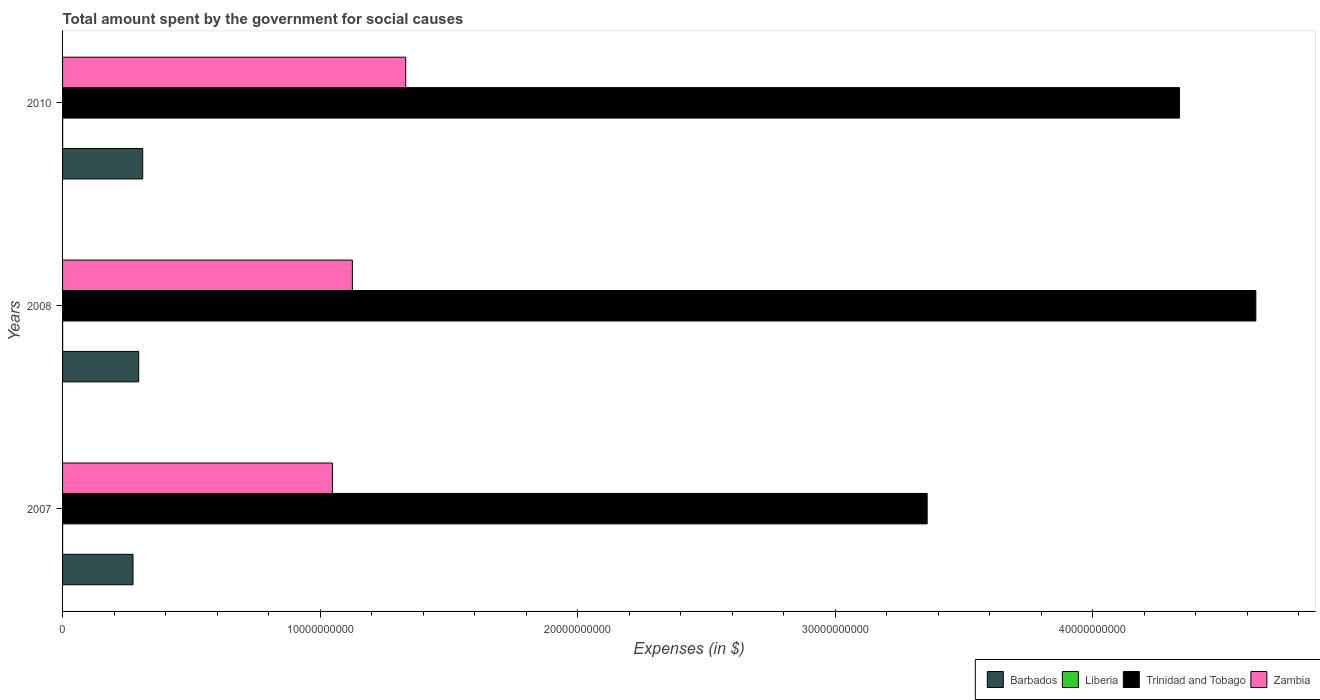How many different coloured bars are there?
Provide a succinct answer. 4. How many groups of bars are there?
Keep it short and to the point. 3. Are the number of bars on each tick of the Y-axis equal?
Make the answer very short. Yes. What is the label of the 3rd group of bars from the top?
Your response must be concise. 2007. What is the amount spent for social causes by the government in Trinidad and Tobago in 2008?
Give a very brief answer. 4.63e+1. Across all years, what is the maximum amount spent for social causes by the government in Zambia?
Your answer should be very brief. 1.33e+1. Across all years, what is the minimum amount spent for social causes by the government in Trinidad and Tobago?
Make the answer very short. 3.36e+1. What is the total amount spent for social causes by the government in Zambia in the graph?
Ensure brevity in your answer.  3.51e+1. What is the difference between the amount spent for social causes by the government in Barbados in 2007 and that in 2010?
Your response must be concise. -3.77e+08. What is the difference between the amount spent for social causes by the government in Barbados in 2010 and the amount spent for social causes by the government in Trinidad and Tobago in 2008?
Provide a short and direct response. -4.32e+1. What is the average amount spent for social causes by the government in Barbados per year?
Your answer should be compact. 2.93e+09. In the year 2008, what is the difference between the amount spent for social causes by the government in Zambia and amount spent for social causes by the government in Liberia?
Offer a terse response. 1.13e+1. In how many years, is the amount spent for social causes by the government in Barbados greater than 18000000000 $?
Make the answer very short. 0. What is the ratio of the amount spent for social causes by the government in Zambia in 2007 to that in 2010?
Your answer should be very brief. 0.79. Is the amount spent for social causes by the government in Zambia in 2007 less than that in 2008?
Provide a short and direct response. Yes. Is the difference between the amount spent for social causes by the government in Zambia in 2007 and 2010 greater than the difference between the amount spent for social causes by the government in Liberia in 2007 and 2010?
Your answer should be compact. No. What is the difference between the highest and the second highest amount spent for social causes by the government in Trinidad and Tobago?
Keep it short and to the point. 2.97e+09. What is the difference between the highest and the lowest amount spent for social causes by the government in Trinidad and Tobago?
Your response must be concise. 1.28e+1. What does the 3rd bar from the top in 2008 represents?
Give a very brief answer. Liberia. What does the 1st bar from the bottom in 2010 represents?
Offer a very short reply. Barbados. Is it the case that in every year, the sum of the amount spent for social causes by the government in Liberia and amount spent for social causes by the government in Barbados is greater than the amount spent for social causes by the government in Zambia?
Offer a terse response. No. Are the values on the major ticks of X-axis written in scientific E-notation?
Your answer should be very brief. No. Does the graph contain grids?
Your answer should be compact. No. How many legend labels are there?
Your answer should be compact. 4. What is the title of the graph?
Your answer should be very brief. Total amount spent by the government for social causes. What is the label or title of the X-axis?
Provide a short and direct response. Expenses (in $). What is the label or title of the Y-axis?
Provide a succinct answer. Years. What is the Expenses (in $) in Barbados in 2007?
Ensure brevity in your answer.  2.73e+09. What is the Expenses (in $) of Liberia in 2007?
Provide a succinct answer. 1.72e+06. What is the Expenses (in $) in Trinidad and Tobago in 2007?
Your answer should be very brief. 3.36e+1. What is the Expenses (in $) of Zambia in 2007?
Your answer should be compact. 1.05e+1. What is the Expenses (in $) of Barbados in 2008?
Ensure brevity in your answer.  2.96e+09. What is the Expenses (in $) in Liberia in 2008?
Offer a terse response. 2.85e+06. What is the Expenses (in $) in Trinidad and Tobago in 2008?
Your answer should be very brief. 4.63e+1. What is the Expenses (in $) in Zambia in 2008?
Provide a short and direct response. 1.13e+1. What is the Expenses (in $) of Barbados in 2010?
Offer a very short reply. 3.11e+09. What is the Expenses (in $) of Liberia in 2010?
Offer a terse response. 3.80e+06. What is the Expenses (in $) in Trinidad and Tobago in 2010?
Ensure brevity in your answer.  4.34e+1. What is the Expenses (in $) in Zambia in 2010?
Ensure brevity in your answer.  1.33e+1. Across all years, what is the maximum Expenses (in $) of Barbados?
Give a very brief answer. 3.11e+09. Across all years, what is the maximum Expenses (in $) of Liberia?
Provide a succinct answer. 3.80e+06. Across all years, what is the maximum Expenses (in $) of Trinidad and Tobago?
Make the answer very short. 4.63e+1. Across all years, what is the maximum Expenses (in $) of Zambia?
Provide a short and direct response. 1.33e+1. Across all years, what is the minimum Expenses (in $) in Barbados?
Offer a terse response. 2.73e+09. Across all years, what is the minimum Expenses (in $) of Liberia?
Keep it short and to the point. 1.72e+06. Across all years, what is the minimum Expenses (in $) of Trinidad and Tobago?
Ensure brevity in your answer.  3.36e+1. Across all years, what is the minimum Expenses (in $) in Zambia?
Your answer should be very brief. 1.05e+1. What is the total Expenses (in $) of Barbados in the graph?
Make the answer very short. 8.80e+09. What is the total Expenses (in $) of Liberia in the graph?
Provide a succinct answer. 8.36e+06. What is the total Expenses (in $) of Trinidad and Tobago in the graph?
Your answer should be very brief. 1.23e+11. What is the total Expenses (in $) of Zambia in the graph?
Provide a succinct answer. 3.51e+1. What is the difference between the Expenses (in $) of Barbados in 2007 and that in 2008?
Offer a very short reply. -2.22e+08. What is the difference between the Expenses (in $) in Liberia in 2007 and that in 2008?
Provide a succinct answer. -1.13e+06. What is the difference between the Expenses (in $) in Trinidad and Tobago in 2007 and that in 2008?
Give a very brief answer. -1.28e+1. What is the difference between the Expenses (in $) in Zambia in 2007 and that in 2008?
Your answer should be very brief. -7.76e+08. What is the difference between the Expenses (in $) of Barbados in 2007 and that in 2010?
Your answer should be very brief. -3.77e+08. What is the difference between the Expenses (in $) of Liberia in 2007 and that in 2010?
Your response must be concise. -2.08e+06. What is the difference between the Expenses (in $) of Trinidad and Tobago in 2007 and that in 2010?
Your answer should be very brief. -9.80e+09. What is the difference between the Expenses (in $) of Zambia in 2007 and that in 2010?
Offer a very short reply. -2.85e+09. What is the difference between the Expenses (in $) of Barbados in 2008 and that in 2010?
Provide a short and direct response. -1.55e+08. What is the difference between the Expenses (in $) in Liberia in 2008 and that in 2010?
Keep it short and to the point. -9.49e+05. What is the difference between the Expenses (in $) of Trinidad and Tobago in 2008 and that in 2010?
Offer a very short reply. 2.97e+09. What is the difference between the Expenses (in $) of Zambia in 2008 and that in 2010?
Offer a very short reply. -2.07e+09. What is the difference between the Expenses (in $) of Barbados in 2007 and the Expenses (in $) of Liberia in 2008?
Make the answer very short. 2.73e+09. What is the difference between the Expenses (in $) in Barbados in 2007 and the Expenses (in $) in Trinidad and Tobago in 2008?
Provide a short and direct response. -4.36e+1. What is the difference between the Expenses (in $) of Barbados in 2007 and the Expenses (in $) of Zambia in 2008?
Offer a very short reply. -8.52e+09. What is the difference between the Expenses (in $) in Liberia in 2007 and the Expenses (in $) in Trinidad and Tobago in 2008?
Your answer should be compact. -4.63e+1. What is the difference between the Expenses (in $) of Liberia in 2007 and the Expenses (in $) of Zambia in 2008?
Keep it short and to the point. -1.13e+1. What is the difference between the Expenses (in $) of Trinidad and Tobago in 2007 and the Expenses (in $) of Zambia in 2008?
Ensure brevity in your answer.  2.23e+1. What is the difference between the Expenses (in $) of Barbados in 2007 and the Expenses (in $) of Liberia in 2010?
Your response must be concise. 2.73e+09. What is the difference between the Expenses (in $) in Barbados in 2007 and the Expenses (in $) in Trinidad and Tobago in 2010?
Your response must be concise. -4.06e+1. What is the difference between the Expenses (in $) of Barbados in 2007 and the Expenses (in $) of Zambia in 2010?
Your answer should be compact. -1.06e+1. What is the difference between the Expenses (in $) of Liberia in 2007 and the Expenses (in $) of Trinidad and Tobago in 2010?
Make the answer very short. -4.34e+1. What is the difference between the Expenses (in $) in Liberia in 2007 and the Expenses (in $) in Zambia in 2010?
Your response must be concise. -1.33e+1. What is the difference between the Expenses (in $) of Trinidad and Tobago in 2007 and the Expenses (in $) of Zambia in 2010?
Offer a terse response. 2.02e+1. What is the difference between the Expenses (in $) of Barbados in 2008 and the Expenses (in $) of Liberia in 2010?
Offer a very short reply. 2.95e+09. What is the difference between the Expenses (in $) of Barbados in 2008 and the Expenses (in $) of Trinidad and Tobago in 2010?
Ensure brevity in your answer.  -4.04e+1. What is the difference between the Expenses (in $) in Barbados in 2008 and the Expenses (in $) in Zambia in 2010?
Provide a succinct answer. -1.04e+1. What is the difference between the Expenses (in $) in Liberia in 2008 and the Expenses (in $) in Trinidad and Tobago in 2010?
Offer a very short reply. -4.34e+1. What is the difference between the Expenses (in $) of Liberia in 2008 and the Expenses (in $) of Zambia in 2010?
Ensure brevity in your answer.  -1.33e+1. What is the difference between the Expenses (in $) in Trinidad and Tobago in 2008 and the Expenses (in $) in Zambia in 2010?
Ensure brevity in your answer.  3.30e+1. What is the average Expenses (in $) in Barbados per year?
Your response must be concise. 2.93e+09. What is the average Expenses (in $) of Liberia per year?
Give a very brief answer. 2.79e+06. What is the average Expenses (in $) of Trinidad and Tobago per year?
Your answer should be very brief. 4.11e+1. What is the average Expenses (in $) in Zambia per year?
Provide a short and direct response. 1.17e+1. In the year 2007, what is the difference between the Expenses (in $) in Barbados and Expenses (in $) in Liberia?
Give a very brief answer. 2.73e+09. In the year 2007, what is the difference between the Expenses (in $) of Barbados and Expenses (in $) of Trinidad and Tobago?
Provide a short and direct response. -3.08e+1. In the year 2007, what is the difference between the Expenses (in $) of Barbados and Expenses (in $) of Zambia?
Make the answer very short. -7.74e+09. In the year 2007, what is the difference between the Expenses (in $) in Liberia and Expenses (in $) in Trinidad and Tobago?
Offer a very short reply. -3.36e+1. In the year 2007, what is the difference between the Expenses (in $) in Liberia and Expenses (in $) in Zambia?
Your response must be concise. -1.05e+1. In the year 2007, what is the difference between the Expenses (in $) in Trinidad and Tobago and Expenses (in $) in Zambia?
Give a very brief answer. 2.31e+1. In the year 2008, what is the difference between the Expenses (in $) of Barbados and Expenses (in $) of Liberia?
Keep it short and to the point. 2.95e+09. In the year 2008, what is the difference between the Expenses (in $) of Barbados and Expenses (in $) of Trinidad and Tobago?
Ensure brevity in your answer.  -4.34e+1. In the year 2008, what is the difference between the Expenses (in $) in Barbados and Expenses (in $) in Zambia?
Keep it short and to the point. -8.30e+09. In the year 2008, what is the difference between the Expenses (in $) of Liberia and Expenses (in $) of Trinidad and Tobago?
Ensure brevity in your answer.  -4.63e+1. In the year 2008, what is the difference between the Expenses (in $) of Liberia and Expenses (in $) of Zambia?
Your answer should be very brief. -1.13e+1. In the year 2008, what is the difference between the Expenses (in $) of Trinidad and Tobago and Expenses (in $) of Zambia?
Give a very brief answer. 3.51e+1. In the year 2010, what is the difference between the Expenses (in $) of Barbados and Expenses (in $) of Liberia?
Make the answer very short. 3.11e+09. In the year 2010, what is the difference between the Expenses (in $) of Barbados and Expenses (in $) of Trinidad and Tobago?
Your answer should be very brief. -4.03e+1. In the year 2010, what is the difference between the Expenses (in $) in Barbados and Expenses (in $) in Zambia?
Provide a short and direct response. -1.02e+1. In the year 2010, what is the difference between the Expenses (in $) in Liberia and Expenses (in $) in Trinidad and Tobago?
Provide a short and direct response. -4.34e+1. In the year 2010, what is the difference between the Expenses (in $) in Liberia and Expenses (in $) in Zambia?
Provide a succinct answer. -1.33e+1. In the year 2010, what is the difference between the Expenses (in $) in Trinidad and Tobago and Expenses (in $) in Zambia?
Your answer should be compact. 3.00e+1. What is the ratio of the Expenses (in $) in Barbados in 2007 to that in 2008?
Offer a very short reply. 0.92. What is the ratio of the Expenses (in $) of Liberia in 2007 to that in 2008?
Ensure brevity in your answer.  0.6. What is the ratio of the Expenses (in $) of Trinidad and Tobago in 2007 to that in 2008?
Provide a short and direct response. 0.72. What is the ratio of the Expenses (in $) of Zambia in 2007 to that in 2008?
Offer a very short reply. 0.93. What is the ratio of the Expenses (in $) of Barbados in 2007 to that in 2010?
Give a very brief answer. 0.88. What is the ratio of the Expenses (in $) of Liberia in 2007 to that in 2010?
Keep it short and to the point. 0.45. What is the ratio of the Expenses (in $) in Trinidad and Tobago in 2007 to that in 2010?
Keep it short and to the point. 0.77. What is the ratio of the Expenses (in $) of Zambia in 2007 to that in 2010?
Ensure brevity in your answer.  0.79. What is the ratio of the Expenses (in $) of Barbados in 2008 to that in 2010?
Ensure brevity in your answer.  0.95. What is the ratio of the Expenses (in $) in Liberia in 2008 to that in 2010?
Provide a succinct answer. 0.75. What is the ratio of the Expenses (in $) in Trinidad and Tobago in 2008 to that in 2010?
Give a very brief answer. 1.07. What is the ratio of the Expenses (in $) of Zambia in 2008 to that in 2010?
Make the answer very short. 0.84. What is the difference between the highest and the second highest Expenses (in $) in Barbados?
Offer a terse response. 1.55e+08. What is the difference between the highest and the second highest Expenses (in $) of Liberia?
Keep it short and to the point. 9.49e+05. What is the difference between the highest and the second highest Expenses (in $) of Trinidad and Tobago?
Give a very brief answer. 2.97e+09. What is the difference between the highest and the second highest Expenses (in $) of Zambia?
Provide a short and direct response. 2.07e+09. What is the difference between the highest and the lowest Expenses (in $) in Barbados?
Your answer should be very brief. 3.77e+08. What is the difference between the highest and the lowest Expenses (in $) in Liberia?
Your answer should be compact. 2.08e+06. What is the difference between the highest and the lowest Expenses (in $) of Trinidad and Tobago?
Provide a short and direct response. 1.28e+1. What is the difference between the highest and the lowest Expenses (in $) of Zambia?
Offer a very short reply. 2.85e+09. 